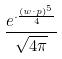<formula> <loc_0><loc_0><loc_500><loc_500>\frac { e ^ { \cdot \frac { ( w \cdot p ) ^ { 5 } } { 4 } } } { \sqrt { 4 \pi } }</formula> 